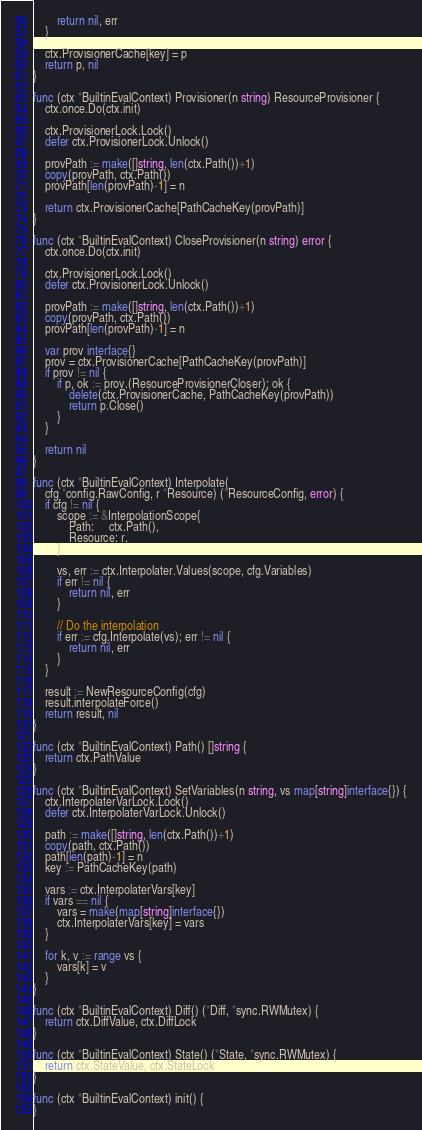<code> <loc_0><loc_0><loc_500><loc_500><_Go_>		return nil, err
	}

	ctx.ProvisionerCache[key] = p
	return p, nil
}

func (ctx *BuiltinEvalContext) Provisioner(n string) ResourceProvisioner {
	ctx.once.Do(ctx.init)

	ctx.ProvisionerLock.Lock()
	defer ctx.ProvisionerLock.Unlock()

	provPath := make([]string, len(ctx.Path())+1)
	copy(provPath, ctx.Path())
	provPath[len(provPath)-1] = n

	return ctx.ProvisionerCache[PathCacheKey(provPath)]
}

func (ctx *BuiltinEvalContext) CloseProvisioner(n string) error {
	ctx.once.Do(ctx.init)

	ctx.ProvisionerLock.Lock()
	defer ctx.ProvisionerLock.Unlock()

	provPath := make([]string, len(ctx.Path())+1)
	copy(provPath, ctx.Path())
	provPath[len(provPath)-1] = n

	var prov interface{}
	prov = ctx.ProvisionerCache[PathCacheKey(provPath)]
	if prov != nil {
		if p, ok := prov.(ResourceProvisionerCloser); ok {
			delete(ctx.ProvisionerCache, PathCacheKey(provPath))
			return p.Close()
		}
	}

	return nil
}

func (ctx *BuiltinEvalContext) Interpolate(
	cfg *config.RawConfig, r *Resource) (*ResourceConfig, error) {
	if cfg != nil {
		scope := &InterpolationScope{
			Path:     ctx.Path(),
			Resource: r,
		}

		vs, err := ctx.Interpolater.Values(scope, cfg.Variables)
		if err != nil {
			return nil, err
		}

		// Do the interpolation
		if err := cfg.Interpolate(vs); err != nil {
			return nil, err
		}
	}

	result := NewResourceConfig(cfg)
	result.interpolateForce()
	return result, nil
}

func (ctx *BuiltinEvalContext) Path() []string {
	return ctx.PathValue
}

func (ctx *BuiltinEvalContext) SetVariables(n string, vs map[string]interface{}) {
	ctx.InterpolaterVarLock.Lock()
	defer ctx.InterpolaterVarLock.Unlock()

	path := make([]string, len(ctx.Path())+1)
	copy(path, ctx.Path())
	path[len(path)-1] = n
	key := PathCacheKey(path)

	vars := ctx.InterpolaterVars[key]
	if vars == nil {
		vars = make(map[string]interface{})
		ctx.InterpolaterVars[key] = vars
	}

	for k, v := range vs {
		vars[k] = v
	}
}

func (ctx *BuiltinEvalContext) Diff() (*Diff, *sync.RWMutex) {
	return ctx.DiffValue, ctx.DiffLock
}

func (ctx *BuiltinEvalContext) State() (*State, *sync.RWMutex) {
	return ctx.StateValue, ctx.StateLock
}

func (ctx *BuiltinEvalContext) init() {
}
</code> 